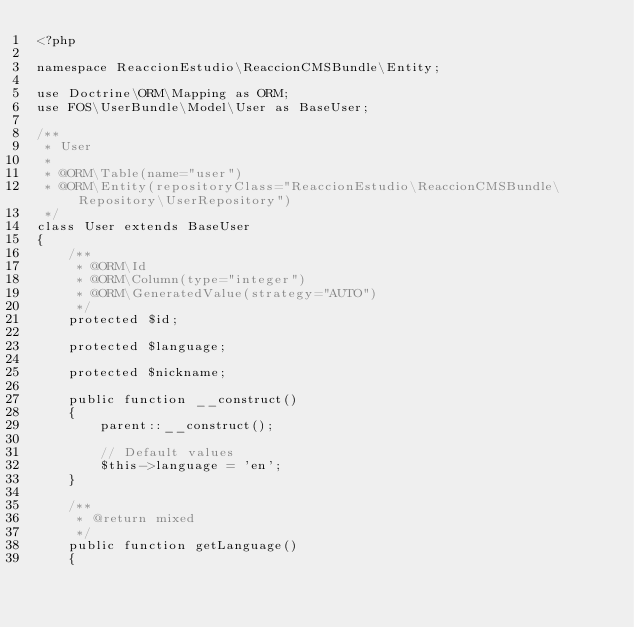<code> <loc_0><loc_0><loc_500><loc_500><_PHP_><?php

namespace ReaccionEstudio\ReaccionCMSBundle\Entity;

use Doctrine\ORM\Mapping as ORM;
use FOS\UserBundle\Model\User as BaseUser;

/**
 * User
 *
 * @ORM\Table(name="user")
 * @ORM\Entity(repositoryClass="ReaccionEstudio\ReaccionCMSBundle\Repository\UserRepository")
 */
class User extends BaseUser
{
    /**
     * @ORM\Id
     * @ORM\Column(type="integer")
     * @ORM\GeneratedValue(strategy="AUTO")
     */
    protected $id;

    protected $language;

    protected $nickname;

    public function __construct()
    {
        parent::__construct();

        // Default values
        $this->language = 'en';
    }

    /**
     * @return mixed
     */
    public function getLanguage()
    {</code> 